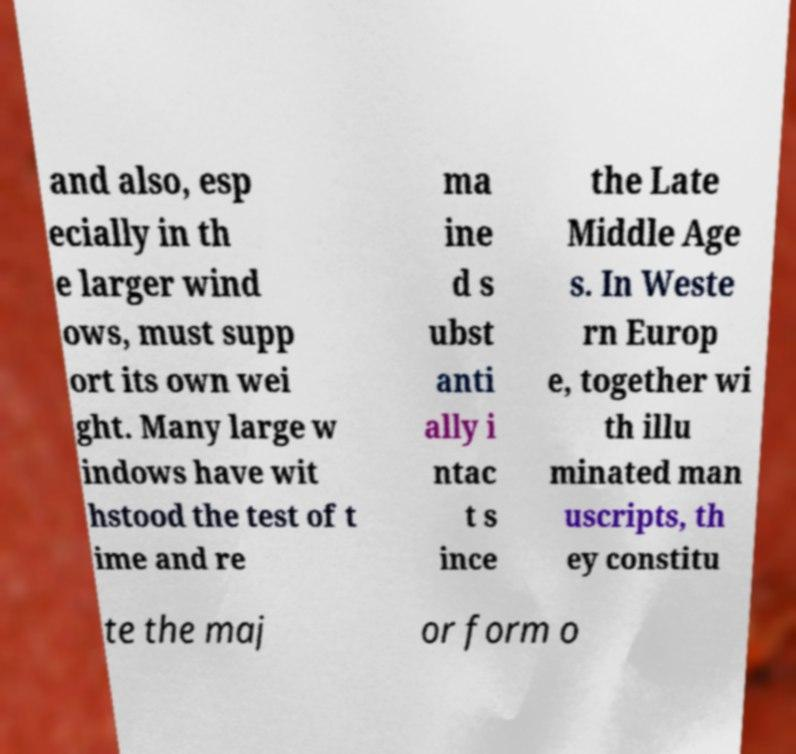Please identify and transcribe the text found in this image. and also, esp ecially in th e larger wind ows, must supp ort its own wei ght. Many large w indows have wit hstood the test of t ime and re ma ine d s ubst anti ally i ntac t s ince the Late Middle Age s. In Weste rn Europ e, together wi th illu minated man uscripts, th ey constitu te the maj or form o 